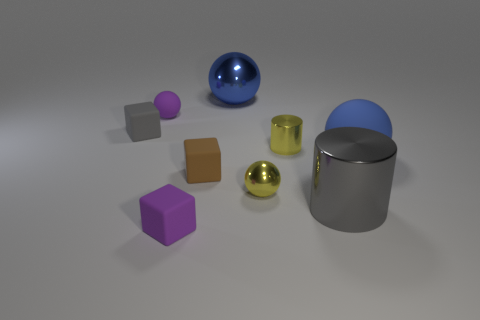Subtract all red cubes. How many blue balls are left? 2 Subtract all large blue rubber spheres. How many spheres are left? 3 Subtract all yellow spheres. How many spheres are left? 3 Subtract all green balls. Subtract all brown cubes. How many balls are left? 4 Add 1 small yellow cylinders. How many objects exist? 10 Add 4 gray shiny cylinders. How many gray shiny cylinders exist? 5 Subtract 1 purple spheres. How many objects are left? 8 Subtract all blocks. How many objects are left? 6 Subtract all large gray shiny cylinders. Subtract all gray shiny objects. How many objects are left? 7 Add 3 purple blocks. How many purple blocks are left? 4 